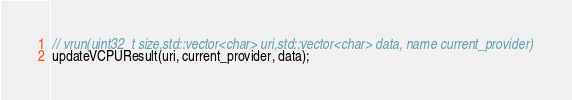Convert code to text. <code><loc_0><loc_0><loc_500><loc_500><_C++_>// vrun(uint32_t size,std::vector<char> uri,std::vector<char> data, name current_provider)
updateVCPUResult(uri, current_provider, data);</code> 